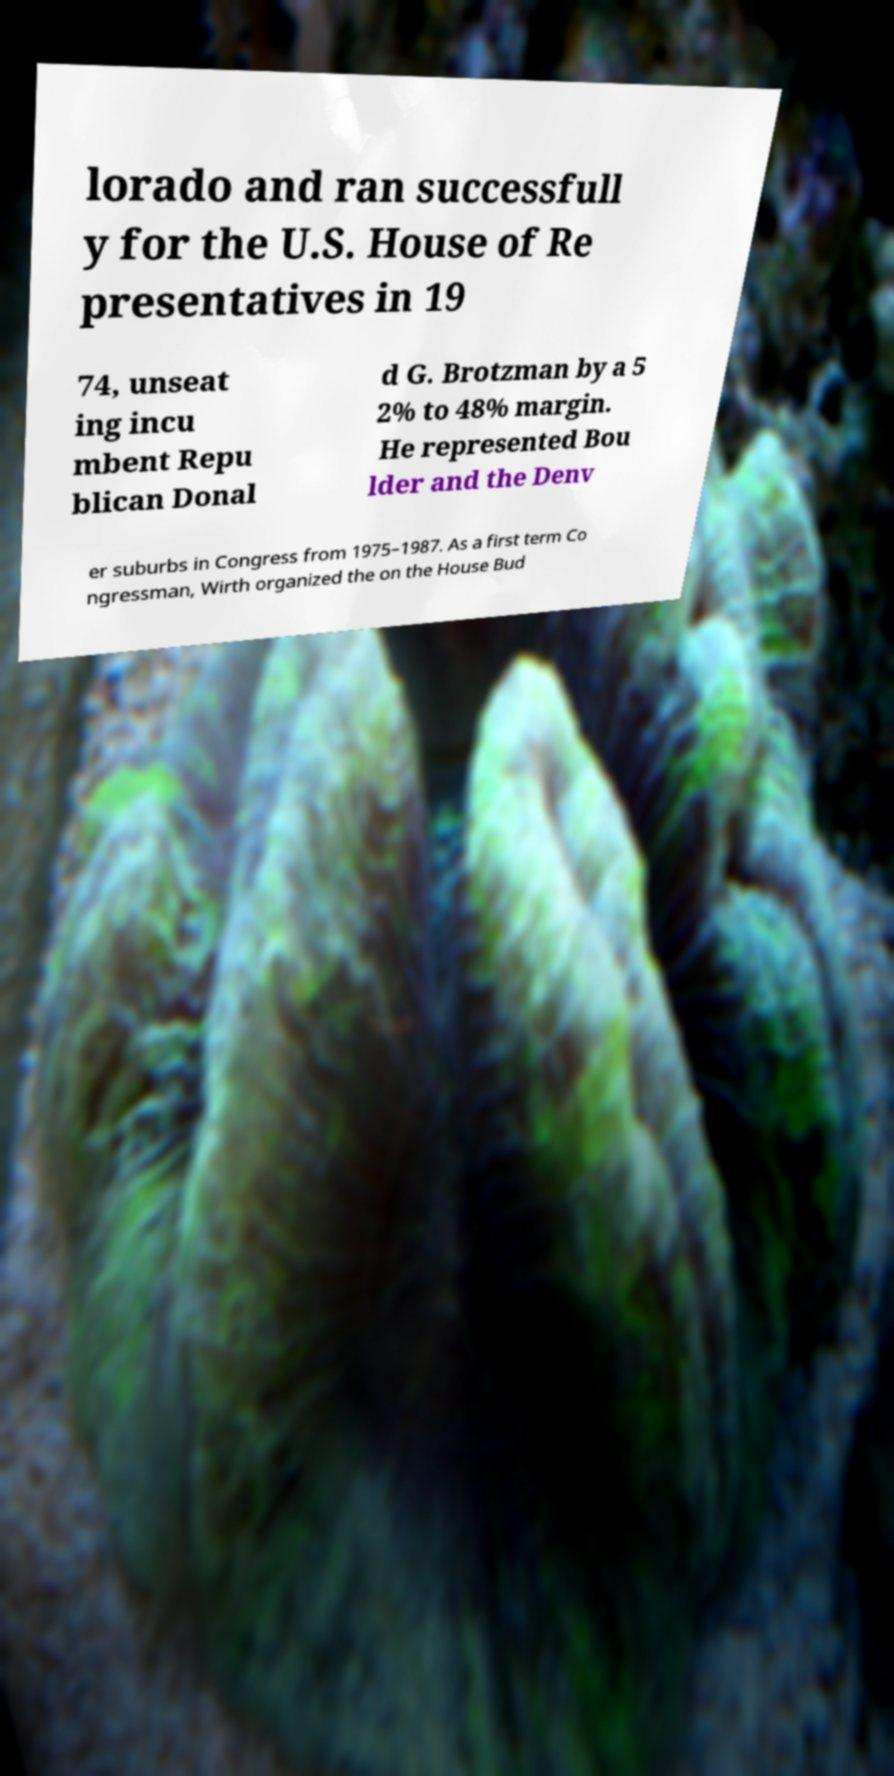I need the written content from this picture converted into text. Can you do that? lorado and ran successfull y for the U.S. House of Re presentatives in 19 74, unseat ing incu mbent Repu blican Donal d G. Brotzman by a 5 2% to 48% margin. He represented Bou lder and the Denv er suburbs in Congress from 1975–1987. As a first term Co ngressman, Wirth organized the on the House Bud 